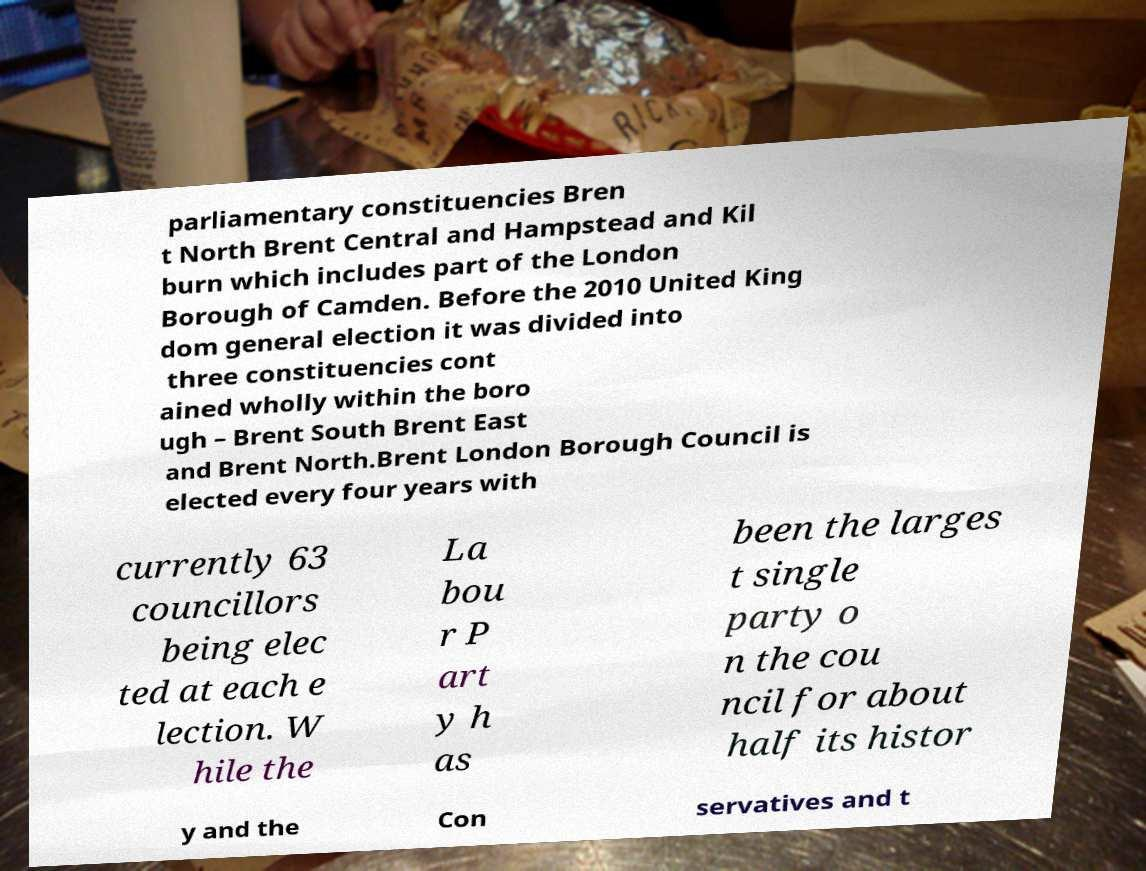Can you accurately transcribe the text from the provided image for me? parliamentary constituencies Bren t North Brent Central and Hampstead and Kil burn which includes part of the London Borough of Camden. Before the 2010 United King dom general election it was divided into three constituencies cont ained wholly within the boro ugh – Brent South Brent East and Brent North.Brent London Borough Council is elected every four years with currently 63 councillors being elec ted at each e lection. W hile the La bou r P art y h as been the larges t single party o n the cou ncil for about half its histor y and the Con servatives and t 